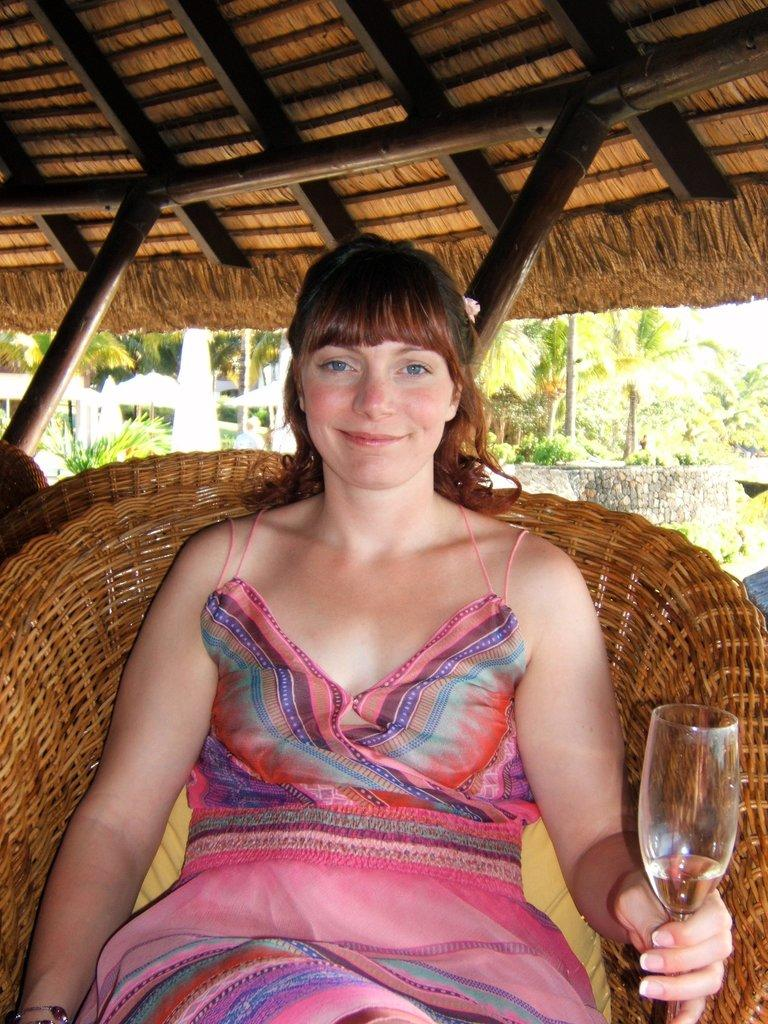Who is the main subject in the image? There is a woman in the image. What is the woman doing in the image? The woman is sitting on a chair and holding a glass. What is the woman's facial expression in the image? The woman has a smile on her face. What can be seen in the background of the image? There are trees in the background of the image. Can you tell me how many grains of rice are on the woman's plate in the image? There is no plate or rice visible in the image, so it is not possible to determine the number of grains of rice. 